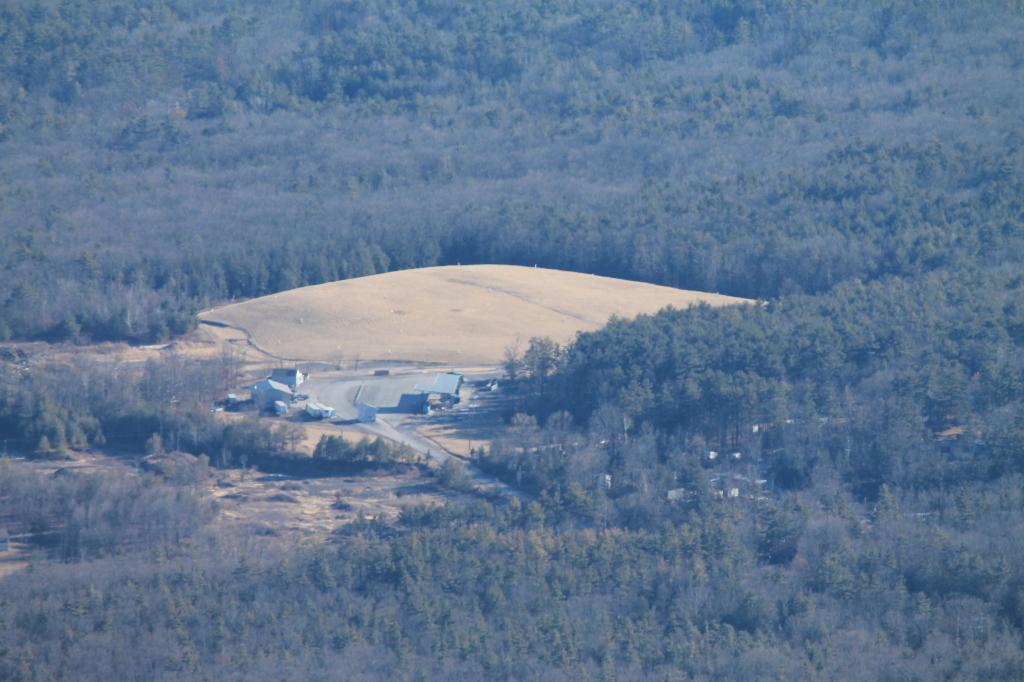What type of environment is shown in the image? The image depicts a forest. What can be seen in the forest? There are many trees in the image. Are there any human-made structures in the forest? Yes, there are a few houses in the image. What is happening in the sky in the image? A plane is landing in the image. What type of path is visible in the image? There is a road in the image. How many degrees does the tree on the left have in the image? Trees do not have degrees; they have branches and leaves. The image shows many trees, but it is not possible to determine the number of degrees for any specific tree. 